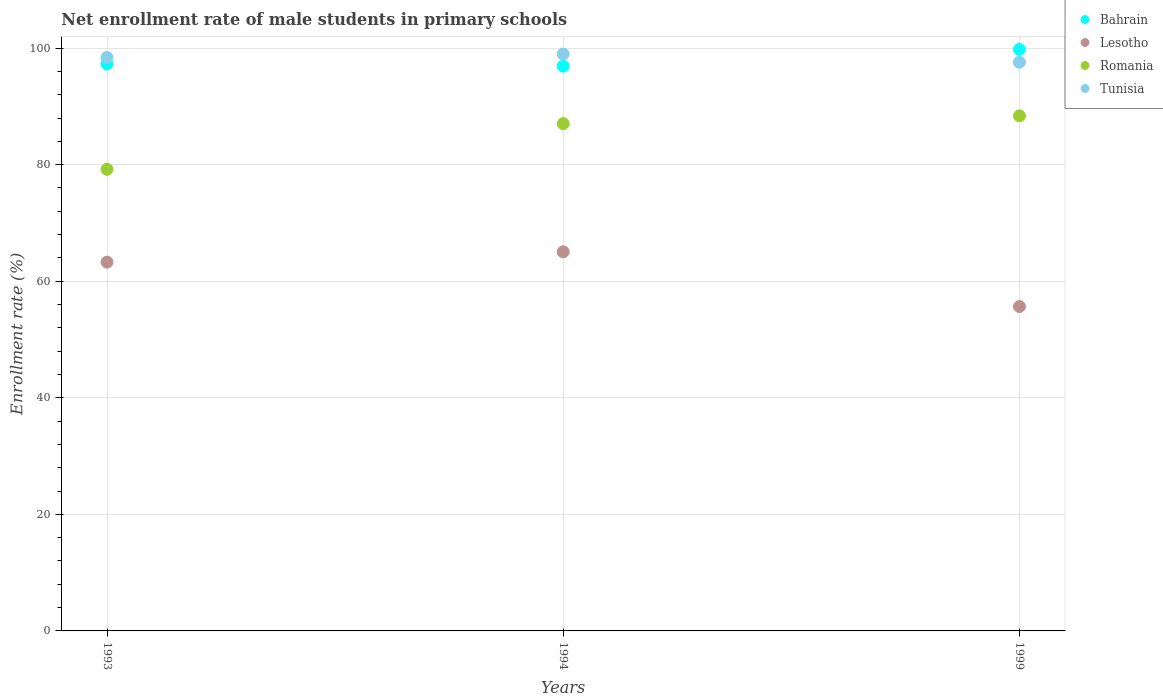How many different coloured dotlines are there?
Your response must be concise. 4. Is the number of dotlines equal to the number of legend labels?
Your answer should be compact. Yes. What is the net enrollment rate of male students in primary schools in Romania in 1999?
Offer a very short reply. 88.37. Across all years, what is the maximum net enrollment rate of male students in primary schools in Romania?
Provide a short and direct response. 88.37. Across all years, what is the minimum net enrollment rate of male students in primary schools in Lesotho?
Ensure brevity in your answer.  55.65. What is the total net enrollment rate of male students in primary schools in Lesotho in the graph?
Provide a short and direct response. 183.97. What is the difference between the net enrollment rate of male students in primary schools in Tunisia in 1994 and that in 1999?
Provide a short and direct response. 1.4. What is the difference between the net enrollment rate of male students in primary schools in Bahrain in 1993 and the net enrollment rate of male students in primary schools in Romania in 1999?
Ensure brevity in your answer.  8.89. What is the average net enrollment rate of male students in primary schools in Tunisia per year?
Give a very brief answer. 98.31. In the year 1994, what is the difference between the net enrollment rate of male students in primary schools in Lesotho and net enrollment rate of male students in primary schools in Tunisia?
Offer a very short reply. -33.92. What is the ratio of the net enrollment rate of male students in primary schools in Romania in 1993 to that in 1999?
Provide a succinct answer. 0.9. Is the net enrollment rate of male students in primary schools in Bahrain in 1993 less than that in 1994?
Ensure brevity in your answer.  No. What is the difference between the highest and the second highest net enrollment rate of male students in primary schools in Lesotho?
Your answer should be very brief. 1.78. What is the difference between the highest and the lowest net enrollment rate of male students in primary schools in Tunisia?
Offer a terse response. 1.4. Is the sum of the net enrollment rate of male students in primary schools in Bahrain in 1994 and 1999 greater than the maximum net enrollment rate of male students in primary schools in Romania across all years?
Your response must be concise. Yes. Is the net enrollment rate of male students in primary schools in Tunisia strictly greater than the net enrollment rate of male students in primary schools in Bahrain over the years?
Give a very brief answer. No. How many dotlines are there?
Your answer should be very brief. 4. What is the difference between two consecutive major ticks on the Y-axis?
Offer a very short reply. 20. Are the values on the major ticks of Y-axis written in scientific E-notation?
Provide a succinct answer. No. Does the graph contain grids?
Keep it short and to the point. Yes. Where does the legend appear in the graph?
Keep it short and to the point. Top right. What is the title of the graph?
Offer a very short reply. Net enrollment rate of male students in primary schools. Does "Netherlands" appear as one of the legend labels in the graph?
Your answer should be compact. No. What is the label or title of the Y-axis?
Ensure brevity in your answer.  Enrollment rate (%). What is the Enrollment rate (%) of Bahrain in 1993?
Give a very brief answer. 97.26. What is the Enrollment rate (%) of Lesotho in 1993?
Provide a short and direct response. 63.27. What is the Enrollment rate (%) in Romania in 1993?
Make the answer very short. 79.19. What is the Enrollment rate (%) in Tunisia in 1993?
Your answer should be compact. 98.38. What is the Enrollment rate (%) in Bahrain in 1994?
Your answer should be compact. 96.89. What is the Enrollment rate (%) of Lesotho in 1994?
Your answer should be very brief. 65.05. What is the Enrollment rate (%) of Romania in 1994?
Your answer should be very brief. 87.04. What is the Enrollment rate (%) in Tunisia in 1994?
Your answer should be compact. 98.97. What is the Enrollment rate (%) in Bahrain in 1999?
Provide a succinct answer. 99.76. What is the Enrollment rate (%) of Lesotho in 1999?
Offer a terse response. 55.65. What is the Enrollment rate (%) in Romania in 1999?
Your answer should be compact. 88.37. What is the Enrollment rate (%) of Tunisia in 1999?
Your answer should be compact. 97.57. Across all years, what is the maximum Enrollment rate (%) of Bahrain?
Keep it short and to the point. 99.76. Across all years, what is the maximum Enrollment rate (%) in Lesotho?
Your answer should be compact. 65.05. Across all years, what is the maximum Enrollment rate (%) of Romania?
Give a very brief answer. 88.37. Across all years, what is the maximum Enrollment rate (%) in Tunisia?
Offer a terse response. 98.97. Across all years, what is the minimum Enrollment rate (%) in Bahrain?
Provide a short and direct response. 96.89. Across all years, what is the minimum Enrollment rate (%) in Lesotho?
Make the answer very short. 55.65. Across all years, what is the minimum Enrollment rate (%) of Romania?
Provide a short and direct response. 79.19. Across all years, what is the minimum Enrollment rate (%) in Tunisia?
Make the answer very short. 97.57. What is the total Enrollment rate (%) of Bahrain in the graph?
Offer a very short reply. 293.91. What is the total Enrollment rate (%) in Lesotho in the graph?
Your answer should be compact. 183.97. What is the total Enrollment rate (%) in Romania in the graph?
Ensure brevity in your answer.  254.6. What is the total Enrollment rate (%) in Tunisia in the graph?
Your response must be concise. 294.92. What is the difference between the Enrollment rate (%) of Bahrain in 1993 and that in 1994?
Your answer should be very brief. 0.37. What is the difference between the Enrollment rate (%) in Lesotho in 1993 and that in 1994?
Offer a terse response. -1.78. What is the difference between the Enrollment rate (%) of Romania in 1993 and that in 1994?
Give a very brief answer. -7.84. What is the difference between the Enrollment rate (%) in Tunisia in 1993 and that in 1994?
Offer a terse response. -0.59. What is the difference between the Enrollment rate (%) of Bahrain in 1993 and that in 1999?
Keep it short and to the point. -2.5. What is the difference between the Enrollment rate (%) of Lesotho in 1993 and that in 1999?
Offer a very short reply. 7.62. What is the difference between the Enrollment rate (%) of Romania in 1993 and that in 1999?
Your answer should be very brief. -9.17. What is the difference between the Enrollment rate (%) in Tunisia in 1993 and that in 1999?
Keep it short and to the point. 0.81. What is the difference between the Enrollment rate (%) in Bahrain in 1994 and that in 1999?
Your answer should be very brief. -2.87. What is the difference between the Enrollment rate (%) in Lesotho in 1994 and that in 1999?
Make the answer very short. 9.39. What is the difference between the Enrollment rate (%) of Romania in 1994 and that in 1999?
Give a very brief answer. -1.33. What is the difference between the Enrollment rate (%) of Tunisia in 1994 and that in 1999?
Offer a very short reply. 1.4. What is the difference between the Enrollment rate (%) in Bahrain in 1993 and the Enrollment rate (%) in Lesotho in 1994?
Provide a short and direct response. 32.21. What is the difference between the Enrollment rate (%) in Bahrain in 1993 and the Enrollment rate (%) in Romania in 1994?
Provide a short and direct response. 10.22. What is the difference between the Enrollment rate (%) in Bahrain in 1993 and the Enrollment rate (%) in Tunisia in 1994?
Your response must be concise. -1.71. What is the difference between the Enrollment rate (%) of Lesotho in 1993 and the Enrollment rate (%) of Romania in 1994?
Offer a very short reply. -23.77. What is the difference between the Enrollment rate (%) in Lesotho in 1993 and the Enrollment rate (%) in Tunisia in 1994?
Make the answer very short. -35.7. What is the difference between the Enrollment rate (%) in Romania in 1993 and the Enrollment rate (%) in Tunisia in 1994?
Your answer should be compact. -19.78. What is the difference between the Enrollment rate (%) of Bahrain in 1993 and the Enrollment rate (%) of Lesotho in 1999?
Provide a succinct answer. 41.61. What is the difference between the Enrollment rate (%) of Bahrain in 1993 and the Enrollment rate (%) of Romania in 1999?
Ensure brevity in your answer.  8.89. What is the difference between the Enrollment rate (%) in Bahrain in 1993 and the Enrollment rate (%) in Tunisia in 1999?
Offer a very short reply. -0.31. What is the difference between the Enrollment rate (%) in Lesotho in 1993 and the Enrollment rate (%) in Romania in 1999?
Offer a very short reply. -25.1. What is the difference between the Enrollment rate (%) of Lesotho in 1993 and the Enrollment rate (%) of Tunisia in 1999?
Offer a terse response. -34.3. What is the difference between the Enrollment rate (%) in Romania in 1993 and the Enrollment rate (%) in Tunisia in 1999?
Ensure brevity in your answer.  -18.37. What is the difference between the Enrollment rate (%) of Bahrain in 1994 and the Enrollment rate (%) of Lesotho in 1999?
Your response must be concise. 41.24. What is the difference between the Enrollment rate (%) in Bahrain in 1994 and the Enrollment rate (%) in Romania in 1999?
Give a very brief answer. 8.52. What is the difference between the Enrollment rate (%) in Bahrain in 1994 and the Enrollment rate (%) in Tunisia in 1999?
Your answer should be very brief. -0.68. What is the difference between the Enrollment rate (%) in Lesotho in 1994 and the Enrollment rate (%) in Romania in 1999?
Provide a short and direct response. -23.32. What is the difference between the Enrollment rate (%) in Lesotho in 1994 and the Enrollment rate (%) in Tunisia in 1999?
Provide a succinct answer. -32.52. What is the difference between the Enrollment rate (%) of Romania in 1994 and the Enrollment rate (%) of Tunisia in 1999?
Offer a terse response. -10.53. What is the average Enrollment rate (%) of Bahrain per year?
Offer a terse response. 97.97. What is the average Enrollment rate (%) of Lesotho per year?
Your response must be concise. 61.32. What is the average Enrollment rate (%) of Romania per year?
Provide a succinct answer. 84.87. What is the average Enrollment rate (%) of Tunisia per year?
Your answer should be very brief. 98.31. In the year 1993, what is the difference between the Enrollment rate (%) of Bahrain and Enrollment rate (%) of Lesotho?
Your response must be concise. 33.99. In the year 1993, what is the difference between the Enrollment rate (%) of Bahrain and Enrollment rate (%) of Romania?
Provide a short and direct response. 18.07. In the year 1993, what is the difference between the Enrollment rate (%) in Bahrain and Enrollment rate (%) in Tunisia?
Offer a terse response. -1.12. In the year 1993, what is the difference between the Enrollment rate (%) in Lesotho and Enrollment rate (%) in Romania?
Make the answer very short. -15.92. In the year 1993, what is the difference between the Enrollment rate (%) in Lesotho and Enrollment rate (%) in Tunisia?
Offer a very short reply. -35.11. In the year 1993, what is the difference between the Enrollment rate (%) in Romania and Enrollment rate (%) in Tunisia?
Make the answer very short. -19.19. In the year 1994, what is the difference between the Enrollment rate (%) of Bahrain and Enrollment rate (%) of Lesotho?
Give a very brief answer. 31.84. In the year 1994, what is the difference between the Enrollment rate (%) of Bahrain and Enrollment rate (%) of Romania?
Provide a succinct answer. 9.85. In the year 1994, what is the difference between the Enrollment rate (%) in Bahrain and Enrollment rate (%) in Tunisia?
Offer a terse response. -2.08. In the year 1994, what is the difference between the Enrollment rate (%) in Lesotho and Enrollment rate (%) in Romania?
Make the answer very short. -21.99. In the year 1994, what is the difference between the Enrollment rate (%) of Lesotho and Enrollment rate (%) of Tunisia?
Make the answer very short. -33.92. In the year 1994, what is the difference between the Enrollment rate (%) in Romania and Enrollment rate (%) in Tunisia?
Your answer should be compact. -11.93. In the year 1999, what is the difference between the Enrollment rate (%) in Bahrain and Enrollment rate (%) in Lesotho?
Provide a short and direct response. 44.11. In the year 1999, what is the difference between the Enrollment rate (%) of Bahrain and Enrollment rate (%) of Romania?
Offer a very short reply. 11.4. In the year 1999, what is the difference between the Enrollment rate (%) of Bahrain and Enrollment rate (%) of Tunisia?
Your answer should be very brief. 2.2. In the year 1999, what is the difference between the Enrollment rate (%) in Lesotho and Enrollment rate (%) in Romania?
Ensure brevity in your answer.  -32.71. In the year 1999, what is the difference between the Enrollment rate (%) in Lesotho and Enrollment rate (%) in Tunisia?
Provide a short and direct response. -41.92. In the year 1999, what is the difference between the Enrollment rate (%) in Romania and Enrollment rate (%) in Tunisia?
Make the answer very short. -9.2. What is the ratio of the Enrollment rate (%) in Lesotho in 1993 to that in 1994?
Ensure brevity in your answer.  0.97. What is the ratio of the Enrollment rate (%) in Romania in 1993 to that in 1994?
Give a very brief answer. 0.91. What is the ratio of the Enrollment rate (%) of Bahrain in 1993 to that in 1999?
Keep it short and to the point. 0.97. What is the ratio of the Enrollment rate (%) in Lesotho in 1993 to that in 1999?
Provide a succinct answer. 1.14. What is the ratio of the Enrollment rate (%) in Romania in 1993 to that in 1999?
Offer a terse response. 0.9. What is the ratio of the Enrollment rate (%) of Tunisia in 1993 to that in 1999?
Offer a very short reply. 1.01. What is the ratio of the Enrollment rate (%) of Bahrain in 1994 to that in 1999?
Ensure brevity in your answer.  0.97. What is the ratio of the Enrollment rate (%) in Lesotho in 1994 to that in 1999?
Your answer should be compact. 1.17. What is the ratio of the Enrollment rate (%) in Romania in 1994 to that in 1999?
Ensure brevity in your answer.  0.98. What is the ratio of the Enrollment rate (%) in Tunisia in 1994 to that in 1999?
Provide a succinct answer. 1.01. What is the difference between the highest and the second highest Enrollment rate (%) in Bahrain?
Provide a short and direct response. 2.5. What is the difference between the highest and the second highest Enrollment rate (%) of Lesotho?
Offer a terse response. 1.78. What is the difference between the highest and the second highest Enrollment rate (%) in Romania?
Your response must be concise. 1.33. What is the difference between the highest and the second highest Enrollment rate (%) in Tunisia?
Keep it short and to the point. 0.59. What is the difference between the highest and the lowest Enrollment rate (%) in Bahrain?
Your response must be concise. 2.87. What is the difference between the highest and the lowest Enrollment rate (%) of Lesotho?
Provide a short and direct response. 9.39. What is the difference between the highest and the lowest Enrollment rate (%) in Romania?
Ensure brevity in your answer.  9.17. What is the difference between the highest and the lowest Enrollment rate (%) in Tunisia?
Your response must be concise. 1.4. 